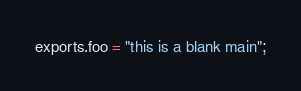<code> <loc_0><loc_0><loc_500><loc_500><_JavaScript_>exports.foo = "this is a blank main";
</code> 